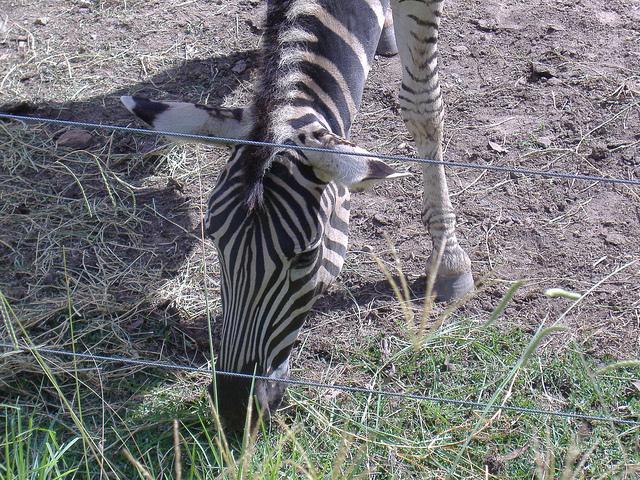What color is the grass?
Keep it brief. Green. What kind of fence is this?
Write a very short answer. Wire. Is the best meal closest to the zebra's tail?
Give a very brief answer. No. 